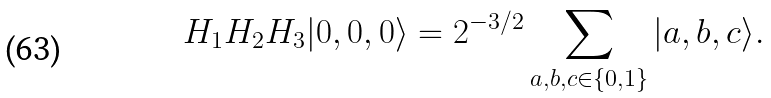<formula> <loc_0><loc_0><loc_500><loc_500>H _ { 1 } H _ { 2 } H _ { 3 } | 0 , 0 , 0 \rangle = 2 ^ { - 3 / 2 } \sum _ { a , b , c \in \{ 0 , 1 \} } | a , b , c \rangle .</formula> 